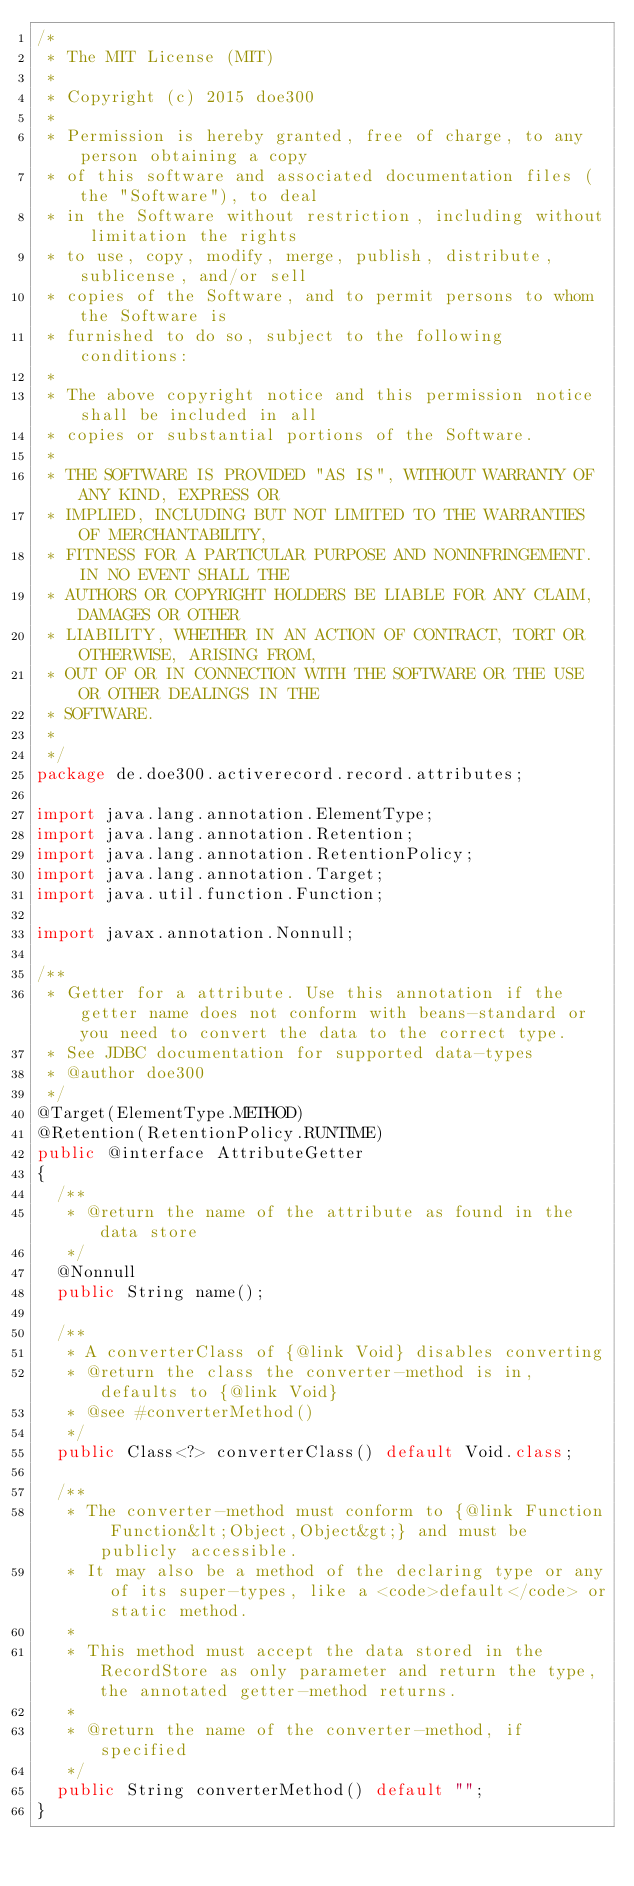<code> <loc_0><loc_0><loc_500><loc_500><_Java_>/*
 * The MIT License (MIT)
 *
 * Copyright (c) 2015 doe300
 *
 * Permission is hereby granted, free of charge, to any person obtaining a copy
 * of this software and associated documentation files (the "Software"), to deal
 * in the Software without restriction, including without limitation the rights
 * to use, copy, modify, merge, publish, distribute, sublicense, and/or sell
 * copies of the Software, and to permit persons to whom the Software is
 * furnished to do so, subject to the following conditions:
 *
 * The above copyright notice and this permission notice shall be included in all
 * copies or substantial portions of the Software.
 *
 * THE SOFTWARE IS PROVIDED "AS IS", WITHOUT WARRANTY OF ANY KIND, EXPRESS OR
 * IMPLIED, INCLUDING BUT NOT LIMITED TO THE WARRANTIES OF MERCHANTABILITY,
 * FITNESS FOR A PARTICULAR PURPOSE AND NONINFRINGEMENT. IN NO EVENT SHALL THE
 * AUTHORS OR COPYRIGHT HOLDERS BE LIABLE FOR ANY CLAIM, DAMAGES OR OTHER
 * LIABILITY, WHETHER IN AN ACTION OF CONTRACT, TORT OR OTHERWISE, ARISING FROM,
 * OUT OF OR IN CONNECTION WITH THE SOFTWARE OR THE USE OR OTHER DEALINGS IN THE
 * SOFTWARE.
 *
 */
package de.doe300.activerecord.record.attributes;

import java.lang.annotation.ElementType;
import java.lang.annotation.Retention;
import java.lang.annotation.RetentionPolicy;
import java.lang.annotation.Target;
import java.util.function.Function;

import javax.annotation.Nonnull;

/**
 * Getter for a attribute. Use this annotation if the getter name does not conform with beans-standard or you need to convert the data to the correct type.
 * See JDBC documentation for supported data-types
 * @author doe300
 */
@Target(ElementType.METHOD)
@Retention(RetentionPolicy.RUNTIME)
public @interface AttributeGetter
{
	/**
	 * @return the name of the attribute as found in the data store
	 */
	@Nonnull
	public String name();

	/**
	 * A converterClass of {@link Void} disables converting
	 * @return the class the converter-method is in, defaults to {@link Void}
	 * @see #converterMethod()
	 */
	public Class<?> converterClass() default Void.class;

	/**
	 * The converter-method must conform to {@link Function Function&lt;Object,Object&gt;} and must be publicly accessible.
	 * It may also be a method of the declaring type or any of its super-types, like a <code>default</code> or static method.
	 *
	 * This method must accept the data stored in the RecordStore as only parameter and return the type, the annotated getter-method returns.
	 *
	 * @return the name of the converter-method, if specified
	 */
	public String converterMethod() default "";
}
</code> 